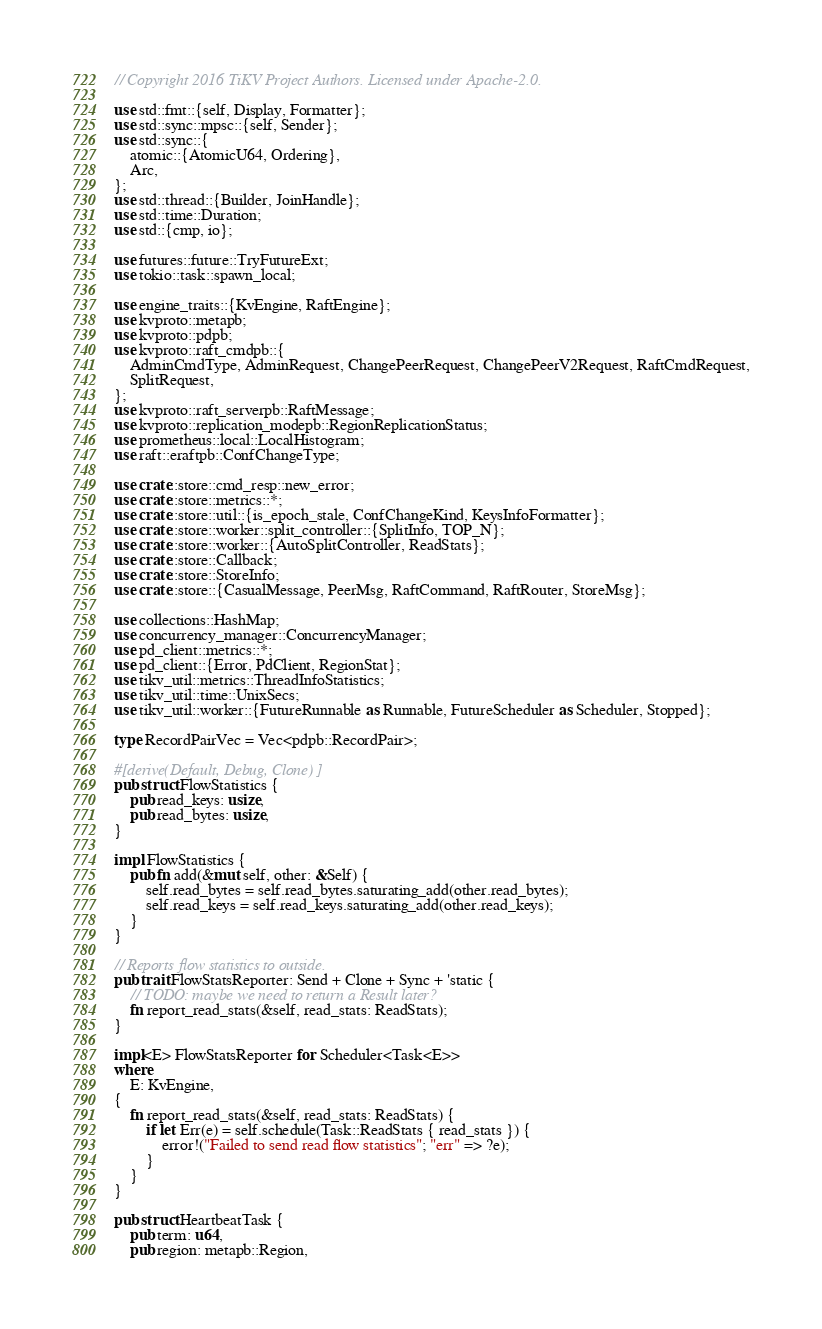Convert code to text. <code><loc_0><loc_0><loc_500><loc_500><_Rust_>// Copyright 2016 TiKV Project Authors. Licensed under Apache-2.0.

use std::fmt::{self, Display, Formatter};
use std::sync::mpsc::{self, Sender};
use std::sync::{
    atomic::{AtomicU64, Ordering},
    Arc,
};
use std::thread::{Builder, JoinHandle};
use std::time::Duration;
use std::{cmp, io};

use futures::future::TryFutureExt;
use tokio::task::spawn_local;

use engine_traits::{KvEngine, RaftEngine};
use kvproto::metapb;
use kvproto::pdpb;
use kvproto::raft_cmdpb::{
    AdminCmdType, AdminRequest, ChangePeerRequest, ChangePeerV2Request, RaftCmdRequest,
    SplitRequest,
};
use kvproto::raft_serverpb::RaftMessage;
use kvproto::replication_modepb::RegionReplicationStatus;
use prometheus::local::LocalHistogram;
use raft::eraftpb::ConfChangeType;

use crate::store::cmd_resp::new_error;
use crate::store::metrics::*;
use crate::store::util::{is_epoch_stale, ConfChangeKind, KeysInfoFormatter};
use crate::store::worker::split_controller::{SplitInfo, TOP_N};
use crate::store::worker::{AutoSplitController, ReadStats};
use crate::store::Callback;
use crate::store::StoreInfo;
use crate::store::{CasualMessage, PeerMsg, RaftCommand, RaftRouter, StoreMsg};

use collections::HashMap;
use concurrency_manager::ConcurrencyManager;
use pd_client::metrics::*;
use pd_client::{Error, PdClient, RegionStat};
use tikv_util::metrics::ThreadInfoStatistics;
use tikv_util::time::UnixSecs;
use tikv_util::worker::{FutureRunnable as Runnable, FutureScheduler as Scheduler, Stopped};

type RecordPairVec = Vec<pdpb::RecordPair>;

#[derive(Default, Debug, Clone)]
pub struct FlowStatistics {
    pub read_keys: usize,
    pub read_bytes: usize,
}

impl FlowStatistics {
    pub fn add(&mut self, other: &Self) {
        self.read_bytes = self.read_bytes.saturating_add(other.read_bytes);
        self.read_keys = self.read_keys.saturating_add(other.read_keys);
    }
}

// Reports flow statistics to outside.
pub trait FlowStatsReporter: Send + Clone + Sync + 'static {
    // TODO: maybe we need to return a Result later?
    fn report_read_stats(&self, read_stats: ReadStats);
}

impl<E> FlowStatsReporter for Scheduler<Task<E>>
where
    E: KvEngine,
{
    fn report_read_stats(&self, read_stats: ReadStats) {
        if let Err(e) = self.schedule(Task::ReadStats { read_stats }) {
            error!("Failed to send read flow statistics"; "err" => ?e);
        }
    }
}

pub struct HeartbeatTask {
    pub term: u64,
    pub region: metapb::Region,</code> 